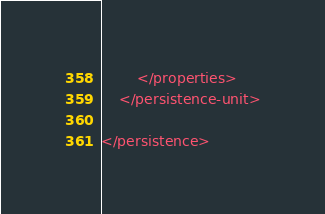Convert code to text. <code><loc_0><loc_0><loc_500><loc_500><_XML_>        </properties>
    </persistence-unit>

</persistence></code> 